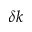<formula> <loc_0><loc_0><loc_500><loc_500>\delta k</formula> 